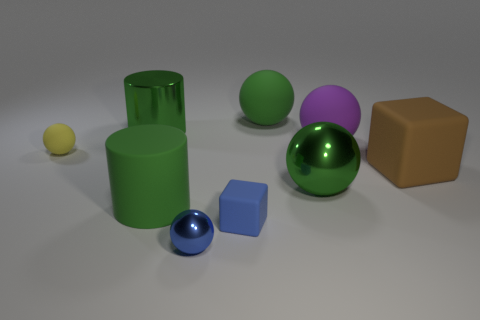What size is the blue cube that is made of the same material as the large brown block?
Your answer should be compact. Small. What number of yellow matte objects are to the right of the small rubber object that is behind the big matte cube?
Your answer should be very brief. 0. Is there another big shiny object of the same shape as the brown object?
Ensure brevity in your answer.  No. What color is the tiny ball in front of the green sphere that is in front of the yellow ball?
Give a very brief answer. Blue. Is the number of tiny metallic objects greater than the number of cyan rubber blocks?
Offer a very short reply. Yes. How many other brown matte blocks have the same size as the brown rubber cube?
Provide a succinct answer. 0. Are the tiny blue ball and the large green cylinder that is in front of the brown block made of the same material?
Give a very brief answer. No. Are there fewer blue cubes than matte blocks?
Your response must be concise. Yes. Are there any other things that have the same color as the large metallic sphere?
Provide a short and direct response. Yes. The tiny yellow thing that is the same material as the brown object is what shape?
Your answer should be very brief. Sphere. 